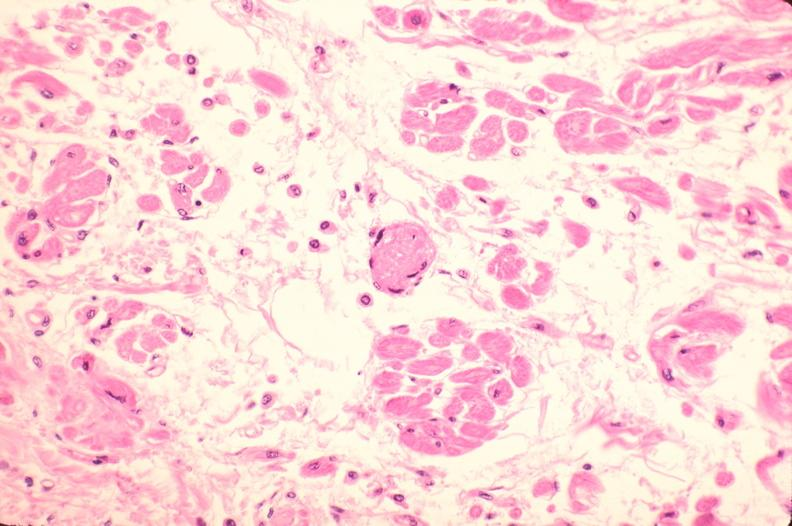does fibrinous peritonitis show heart, microthrombi, thrombotic thrombocytopenic purpura?
Answer the question using a single word or phrase. No 